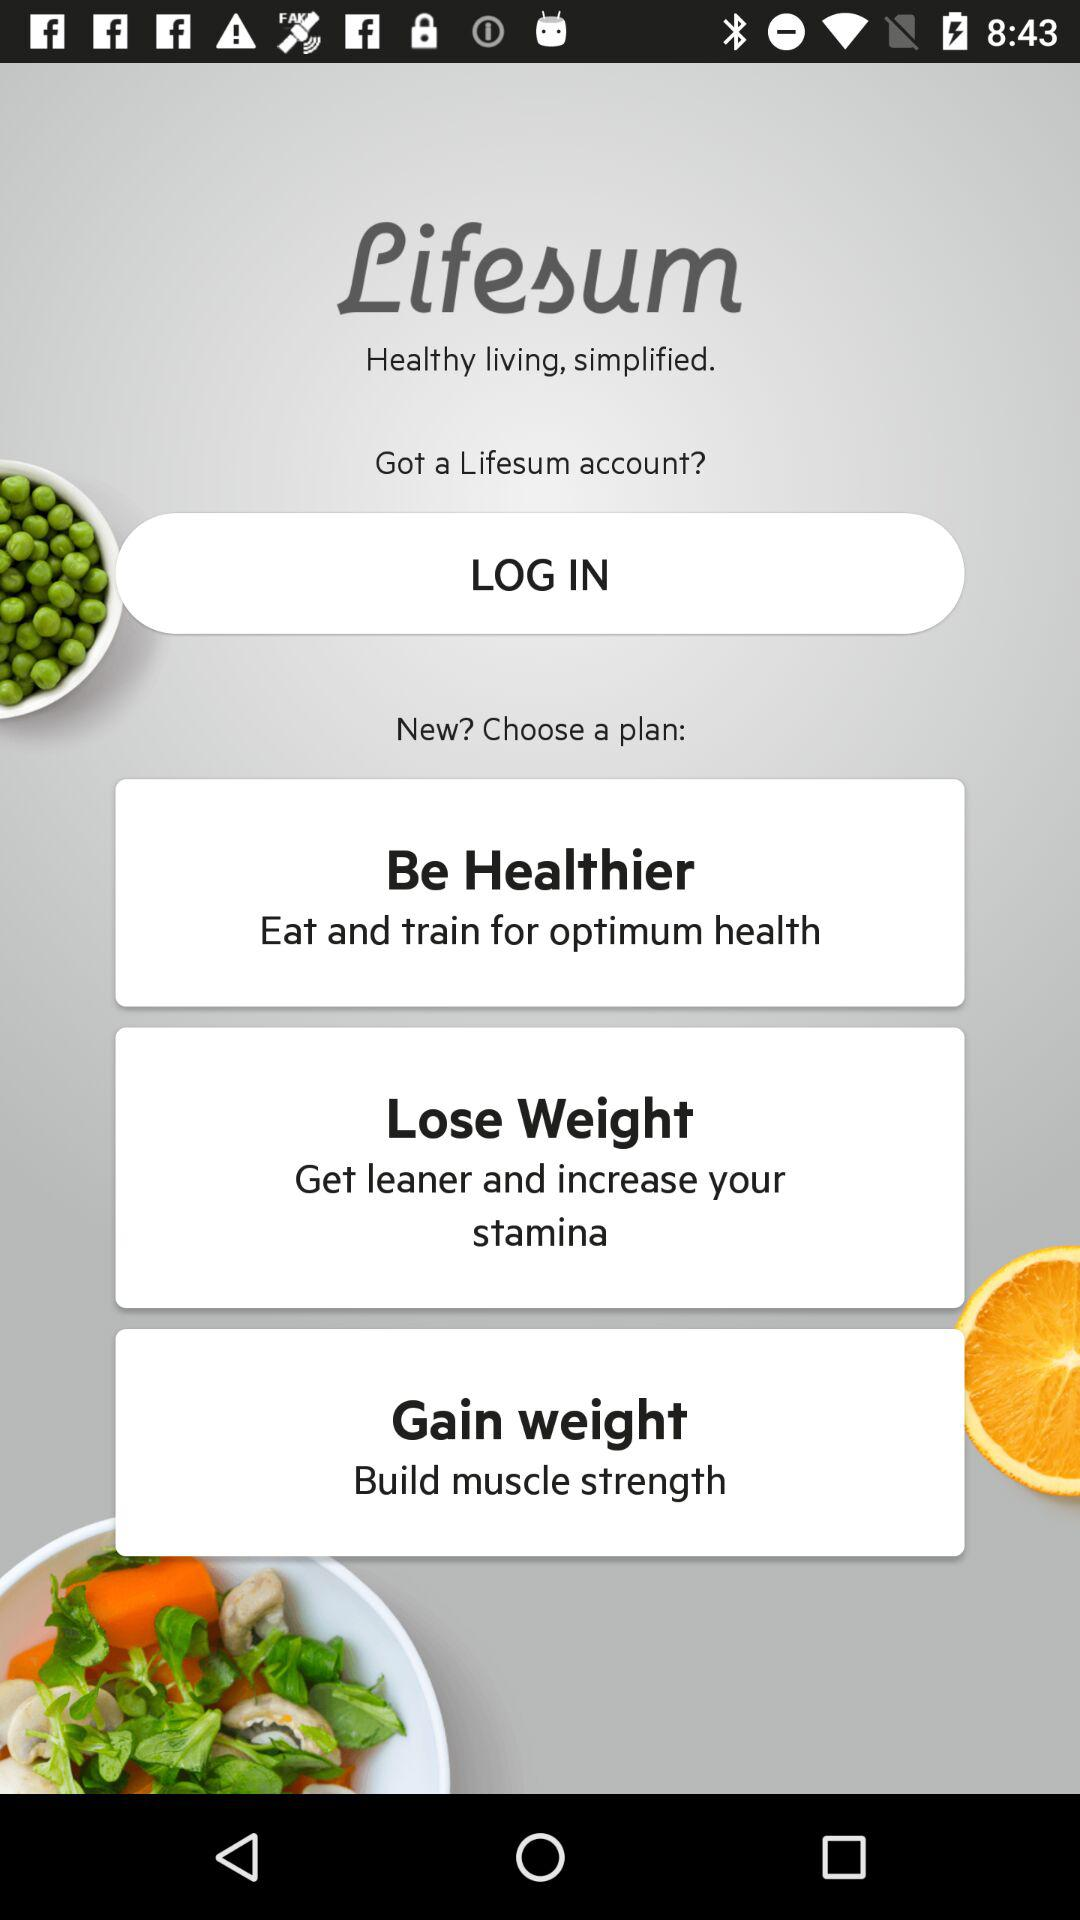What plans are there for the new users? There are three plans for the new users: "Be Healthier", "Lose Weight", and "Gain weight". 